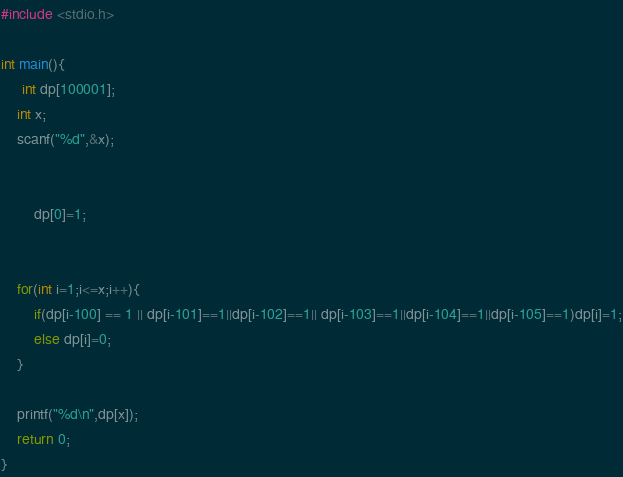Convert code to text. <code><loc_0><loc_0><loc_500><loc_500><_C_>#include <stdio.h>

int main(){
	 int dp[100001];
	int x;
	scanf("%d",&x);
	
	
		dp[0]=1;
	
	
	for(int i=1;i<=x;i++){
		if(dp[i-100] == 1 || dp[i-101]==1||dp[i-102]==1|| dp[i-103]==1||dp[i-104]==1||dp[i-105]==1)dp[i]=1;
		else dp[i]=0;
	}

	printf("%d\n",dp[x]);
	return 0;
}</code> 